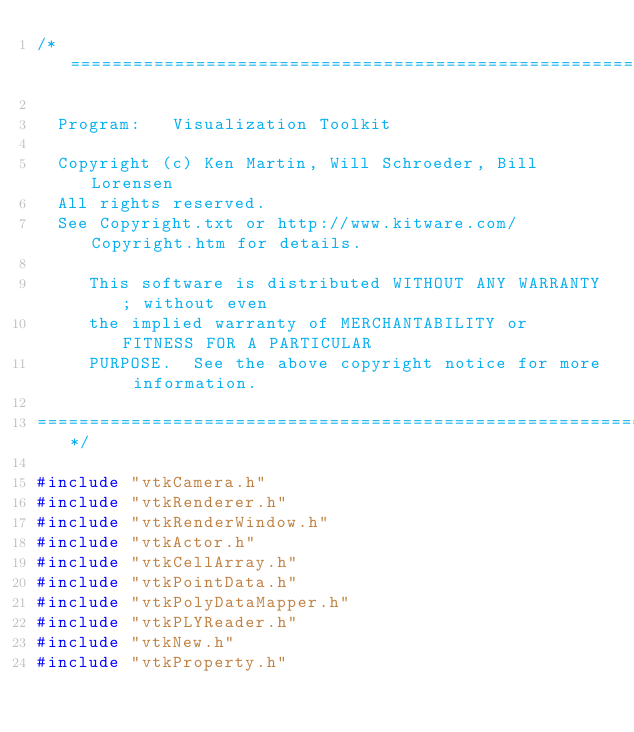Convert code to text. <code><loc_0><loc_0><loc_500><loc_500><_C++_>/*=========================================================================

  Program:   Visualization Toolkit

  Copyright (c) Ken Martin, Will Schroeder, Bill Lorensen
  All rights reserved.
  See Copyright.txt or http://www.kitware.com/Copyright.htm for details.

     This software is distributed WITHOUT ANY WARRANTY; without even
     the implied warranty of MERCHANTABILITY or FITNESS FOR A PARTICULAR
     PURPOSE.  See the above copyright notice for more information.

=========================================================================*/

#include "vtkCamera.h"
#include "vtkRenderer.h"
#include "vtkRenderWindow.h"
#include "vtkActor.h"
#include "vtkCellArray.h"
#include "vtkPointData.h"
#include "vtkPolyDataMapper.h"
#include "vtkPLYReader.h"
#include "vtkNew.h"
#include "vtkProperty.h"</code> 